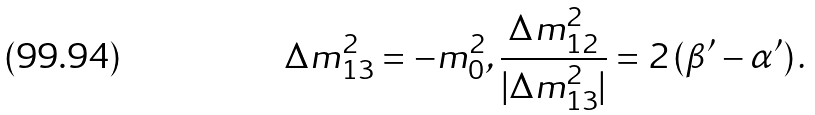<formula> <loc_0><loc_0><loc_500><loc_500>\Delta m ^ { 2 } _ { 1 3 } = - m _ { 0 } ^ { 2 } , \frac { \Delta m ^ { 2 } _ { 1 2 } } { | \Delta m ^ { 2 } _ { 1 3 } | } = 2 \left ( \beta ^ { \prime } - \alpha ^ { \prime } \right ) .</formula> 